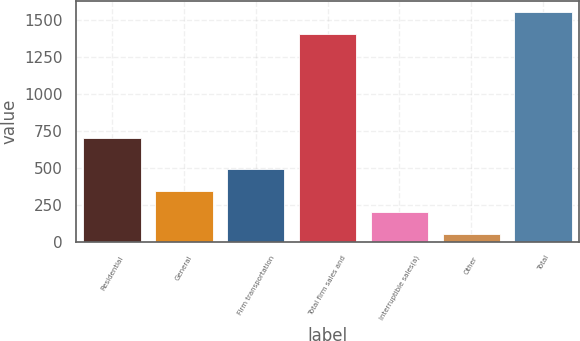Convert chart. <chart><loc_0><loc_0><loc_500><loc_500><bar_chart><fcel>Residential<fcel>General<fcel>Firm transportation<fcel>Total firm sales and<fcel>Interruptible sales(a)<fcel>Other<fcel>Total<nl><fcel>704<fcel>345.8<fcel>492.7<fcel>1404<fcel>198.9<fcel>52<fcel>1550.9<nl></chart> 